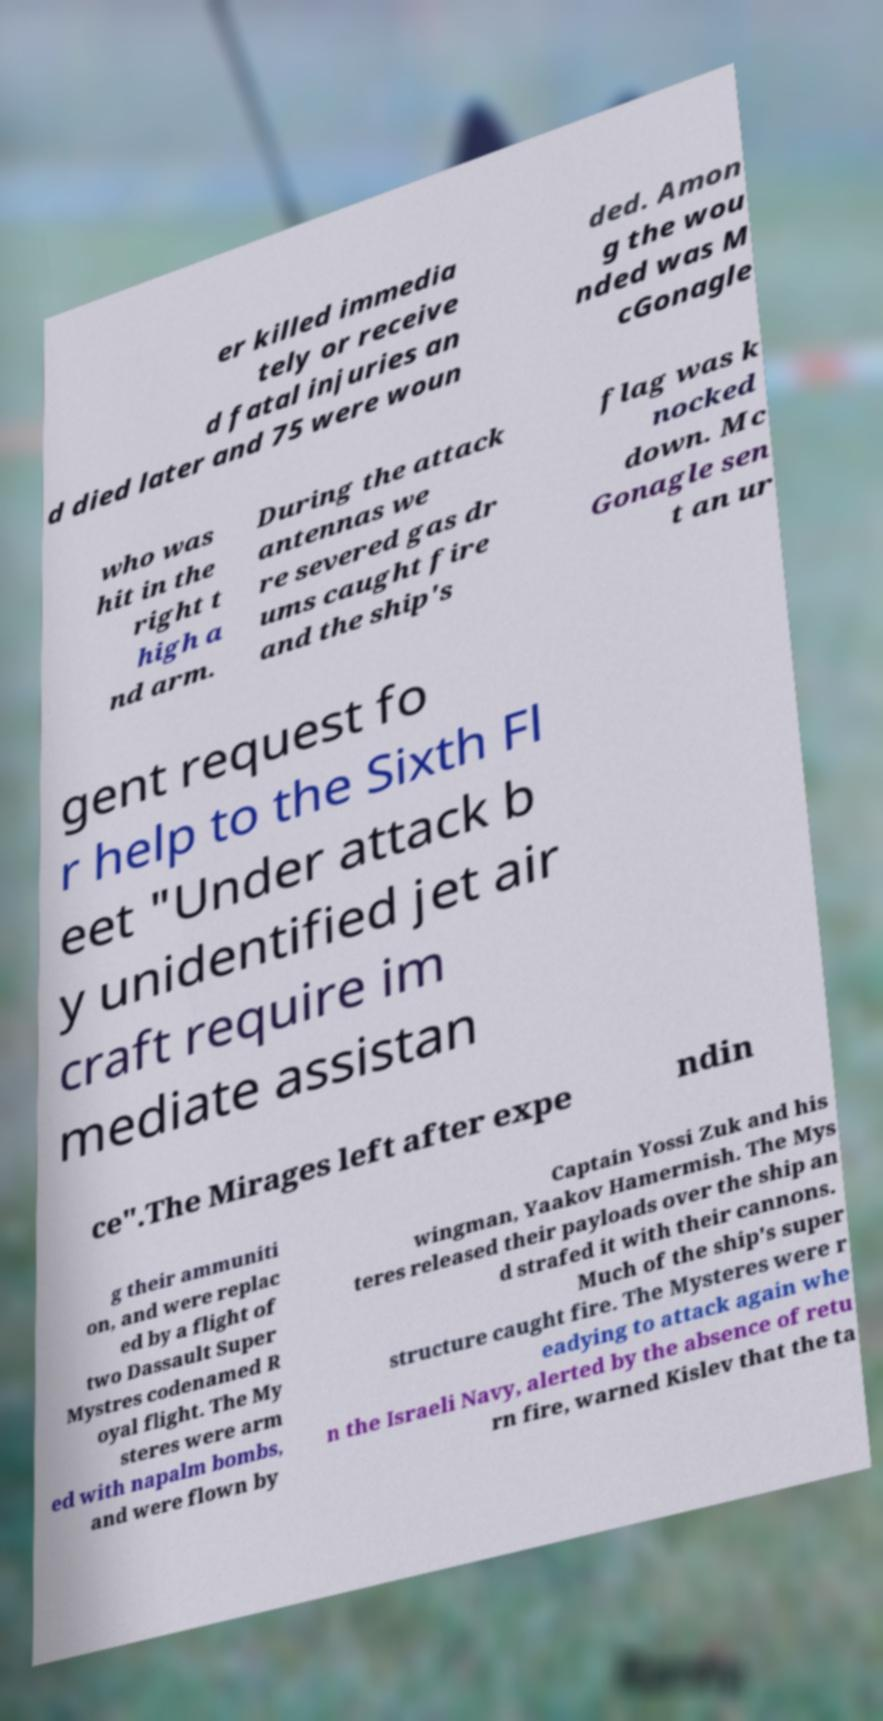Could you assist in decoding the text presented in this image and type it out clearly? er killed immedia tely or receive d fatal injuries an d died later and 75 were woun ded. Amon g the wou nded was M cGonagle who was hit in the right t high a nd arm. During the attack antennas we re severed gas dr ums caught fire and the ship's flag was k nocked down. Mc Gonagle sen t an ur gent request fo r help to the Sixth Fl eet "Under attack b y unidentified jet air craft require im mediate assistan ce".The Mirages left after expe ndin g their ammuniti on, and were replac ed by a flight of two Dassault Super Mystres codenamed R oyal flight. The My steres were arm ed with napalm bombs, and were flown by Captain Yossi Zuk and his wingman, Yaakov Hamermish. The Mys teres released their payloads over the ship an d strafed it with their cannons. Much of the ship's super structure caught fire. The Mysteres were r eadying to attack again whe n the Israeli Navy, alerted by the absence of retu rn fire, warned Kislev that the ta 